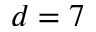Convert formula to latex. <formula><loc_0><loc_0><loc_500><loc_500>d = 7</formula> 